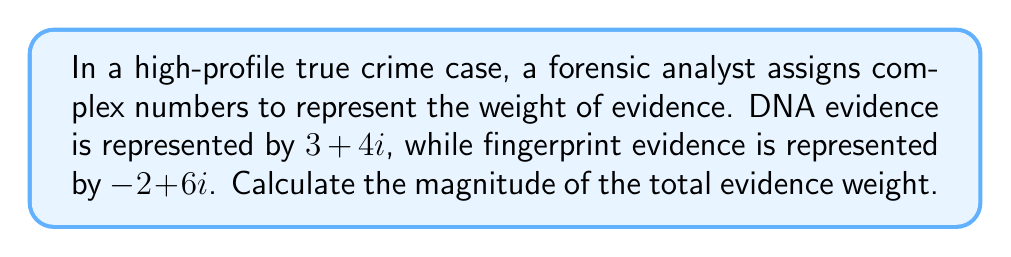Teach me how to tackle this problem. To solve this problem, we'll follow these steps:

1) First, we need to add the complex numbers representing the two pieces of evidence:
   $$(3 + 4i) + (-2 + 6i) = (3 - 2) + (4 + 6)i = 1 + 10i$$

2) The total evidence weight is represented by the complex number $1 + 10i$.

3) To calculate the magnitude of a complex number $a + bi$, we use the formula:
   $$|a + bi| = \sqrt{a^2 + b^2}$$

4) In this case, $a = 1$ and $b = 10$. Let's substitute these values:
   $$|1 + 10i| = \sqrt{1^2 + 10^2}$$

5) Simplify inside the square root:
   $$\sqrt{1 + 100} = \sqrt{101}$$

6) The square root of 101 cannot be simplified further, so this is our final answer.
Answer: $\sqrt{101}$ 